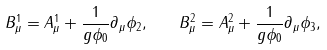Convert formula to latex. <formula><loc_0><loc_0><loc_500><loc_500>B ^ { 1 } _ { \mu } = A ^ { 1 } _ { \mu } + \frac { 1 } { g \phi _ { 0 } } \partial _ { \mu } \phi _ { 2 } , \quad B ^ { 2 } _ { \mu } = A ^ { 2 } _ { \mu } + \frac { 1 } { g \phi _ { 0 } } \partial _ { \mu } \phi _ { 3 } ,</formula> 